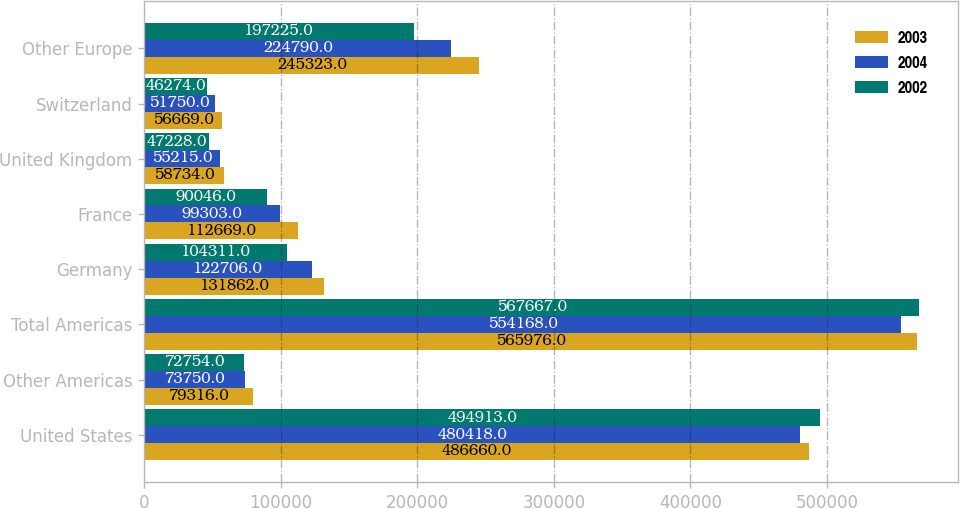Convert chart. <chart><loc_0><loc_0><loc_500><loc_500><stacked_bar_chart><ecel><fcel>United States<fcel>Other Americas<fcel>Total Americas<fcel>Germany<fcel>France<fcel>United Kingdom<fcel>Switzerland<fcel>Other Europe<nl><fcel>2003<fcel>486660<fcel>79316<fcel>565976<fcel>131862<fcel>112669<fcel>58734<fcel>56669<fcel>245323<nl><fcel>2004<fcel>480418<fcel>73750<fcel>554168<fcel>122706<fcel>99303<fcel>55215<fcel>51750<fcel>224790<nl><fcel>2002<fcel>494913<fcel>72754<fcel>567667<fcel>104311<fcel>90046<fcel>47228<fcel>46274<fcel>197225<nl></chart> 